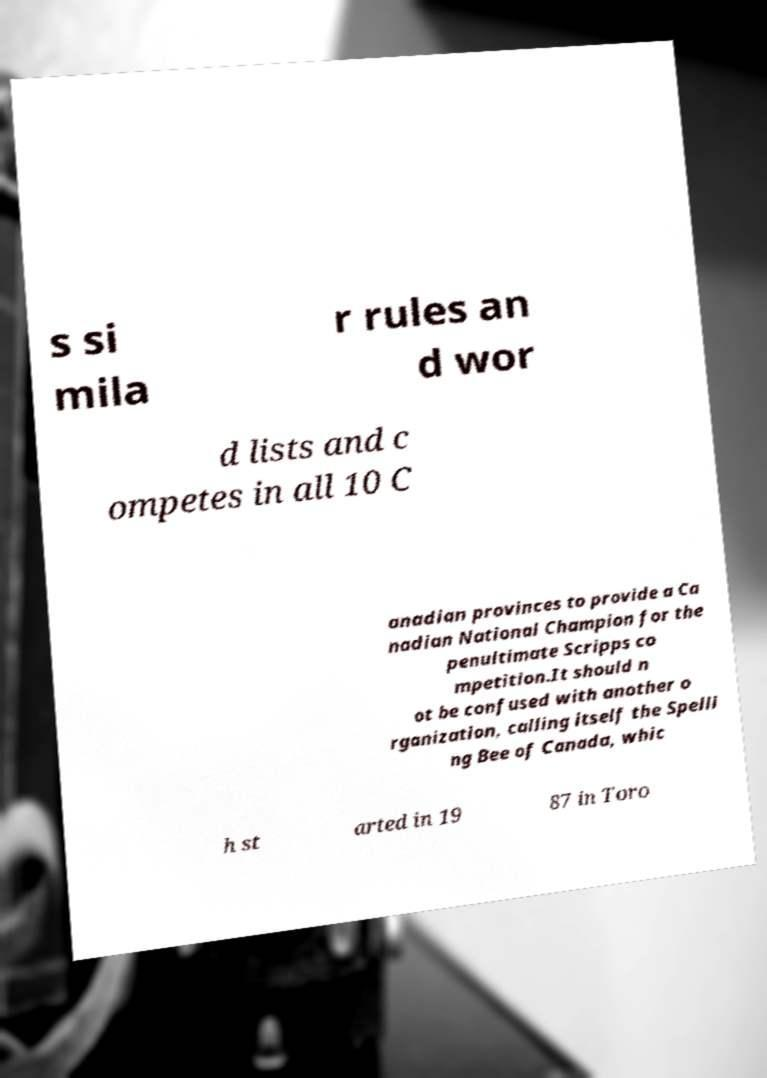Could you extract and type out the text from this image? s si mila r rules an d wor d lists and c ompetes in all 10 C anadian provinces to provide a Ca nadian National Champion for the penultimate Scripps co mpetition.It should n ot be confused with another o rganization, calling itself the Spelli ng Bee of Canada, whic h st arted in 19 87 in Toro 